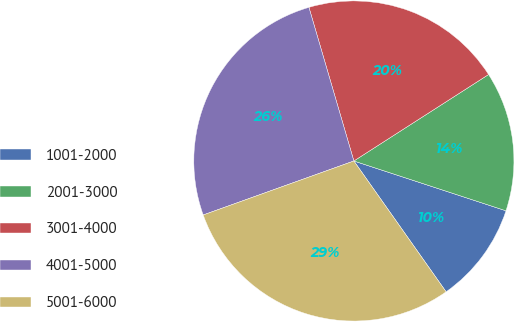<chart> <loc_0><loc_0><loc_500><loc_500><pie_chart><fcel>1001-2000<fcel>2001-3000<fcel>3001-4000<fcel>4001-5000<fcel>5001-6000<nl><fcel>10.19%<fcel>14.12%<fcel>20.45%<fcel>25.95%<fcel>29.3%<nl></chart> 